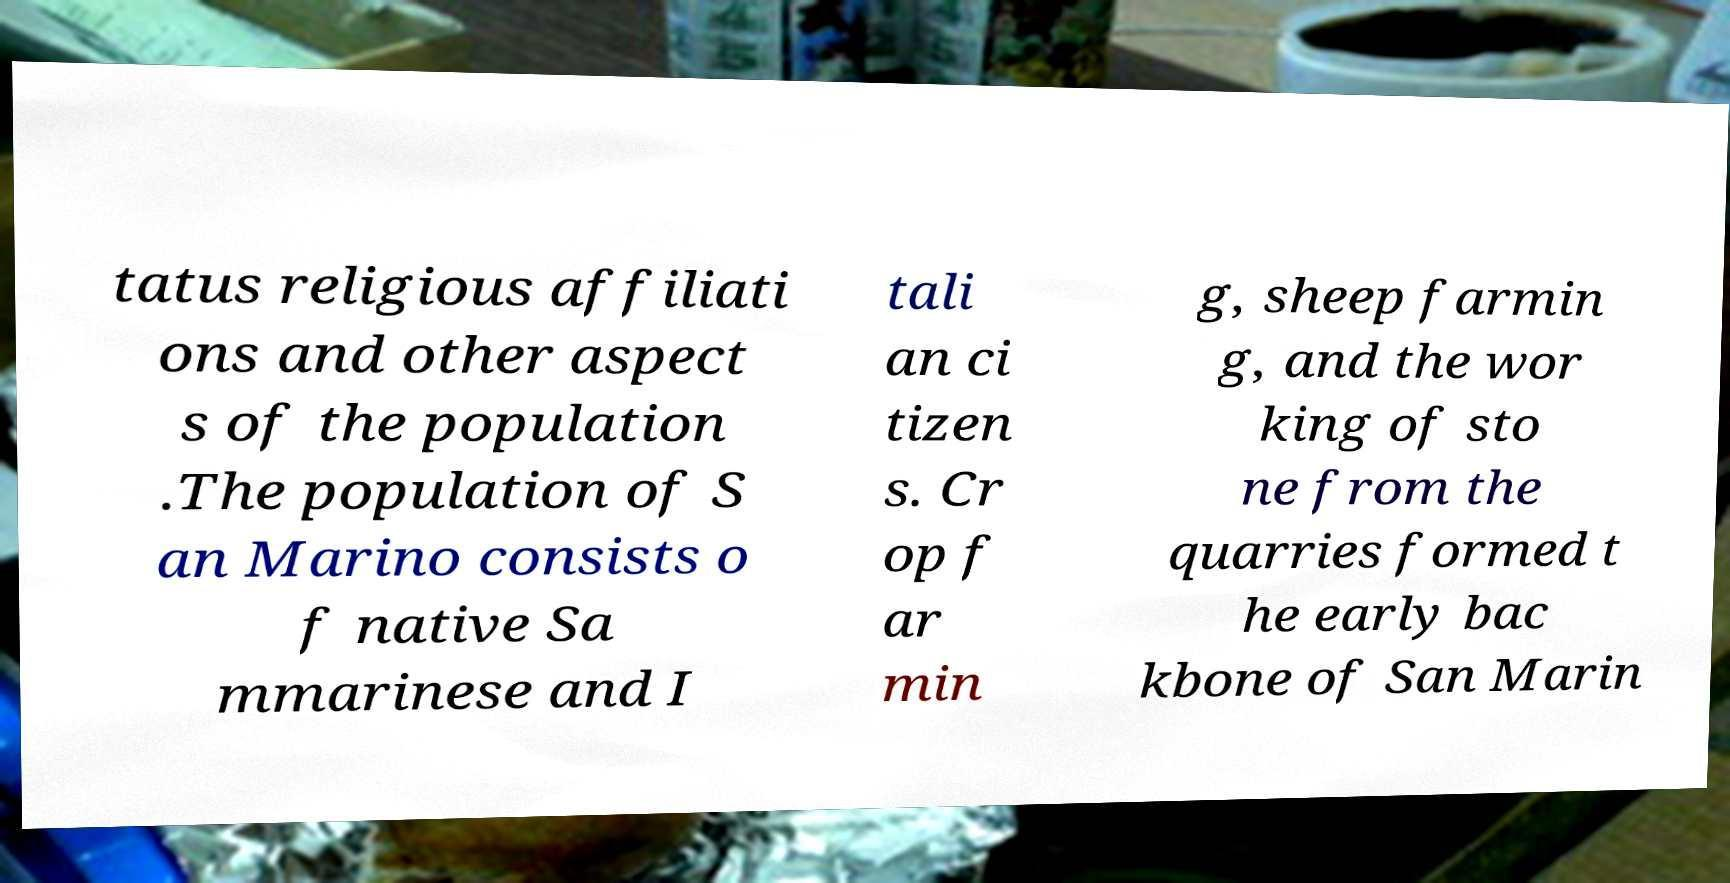Please identify and transcribe the text found in this image. tatus religious affiliati ons and other aspect s of the population .The population of S an Marino consists o f native Sa mmarinese and I tali an ci tizen s. Cr op f ar min g, sheep farmin g, and the wor king of sto ne from the quarries formed t he early bac kbone of San Marin 